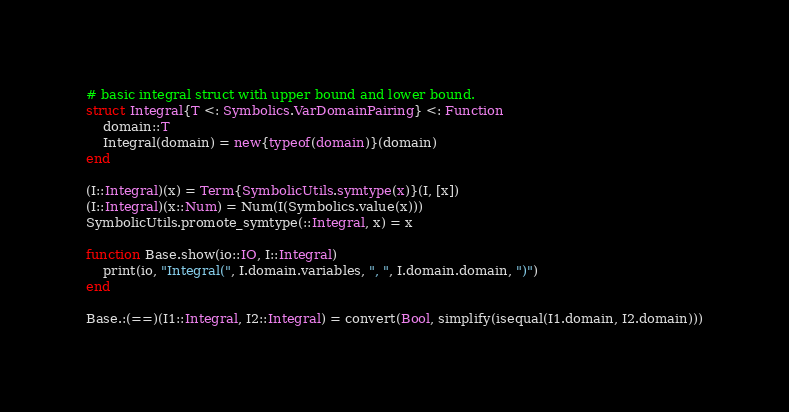Convert code to text. <code><loc_0><loc_0><loc_500><loc_500><_Julia_># basic integral struct with upper bound and lower bound.
struct Integral{T <: Symbolics.VarDomainPairing} <: Function
    domain::T
    Integral(domain) = new{typeof(domain)}(domain)
end

(I::Integral)(x) = Term{SymbolicUtils.symtype(x)}(I, [x])
(I::Integral)(x::Num) = Num(I(Symbolics.value(x)))
SymbolicUtils.promote_symtype(::Integral, x) = x

function Base.show(io::IO, I::Integral)
    print(io, "Integral(", I.domain.variables, ", ", I.domain.domain, ")")
end

Base.:(==)(I1::Integral, I2::Integral) = convert(Bool, simplify(isequal(I1.domain, I2.domain)))
</code> 